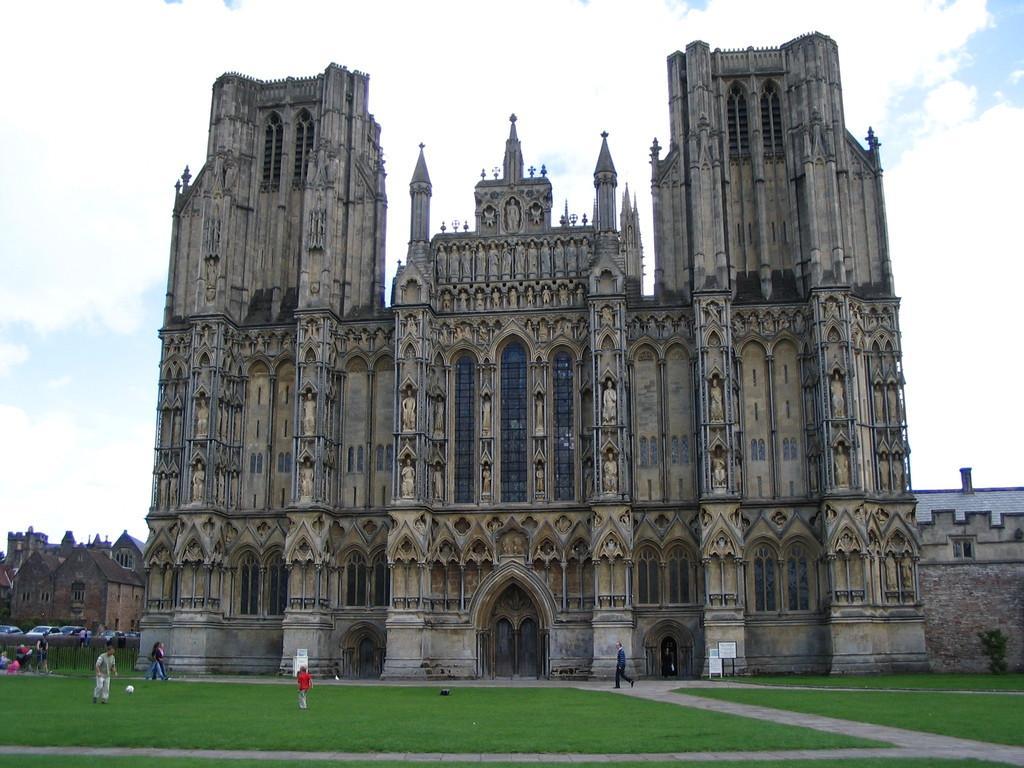Please provide a concise description of this image. It looks like a monument and in front of that there is a lot of grass and people are playing and walking around the grass. In the left side there is another building and in the background there is a sky. 